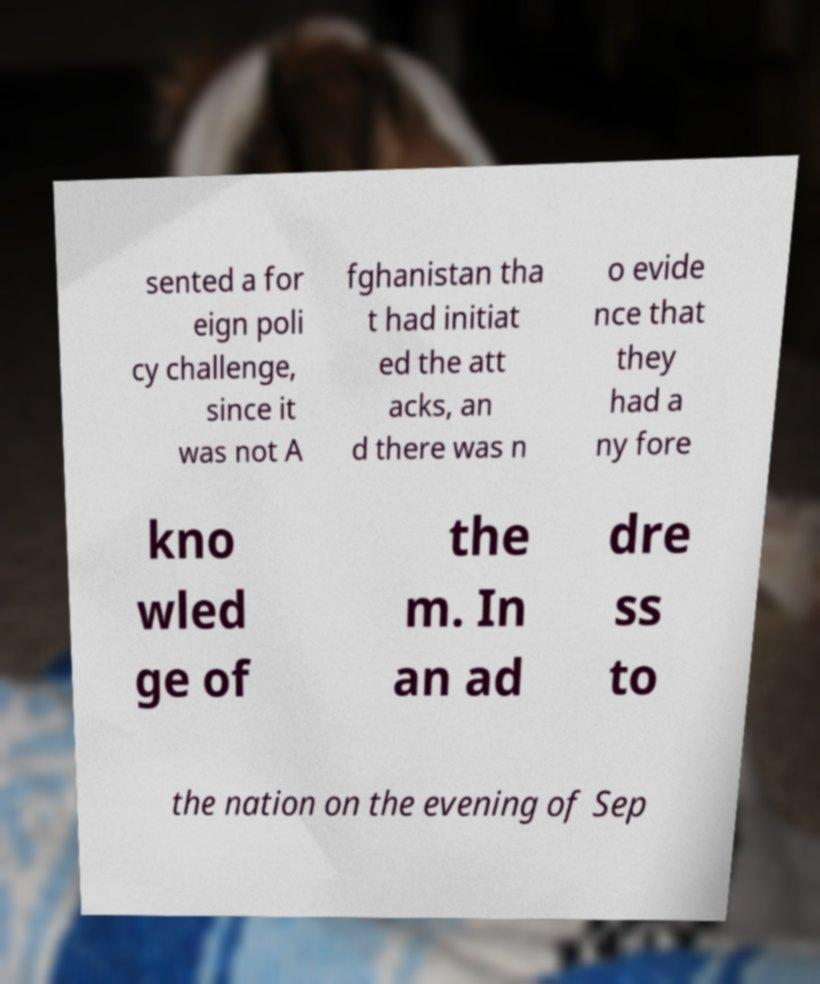For documentation purposes, I need the text within this image transcribed. Could you provide that? sented a for eign poli cy challenge, since it was not A fghanistan tha t had initiat ed the att acks, an d there was n o evide nce that they had a ny fore kno wled ge of the m. In an ad dre ss to the nation on the evening of Sep 